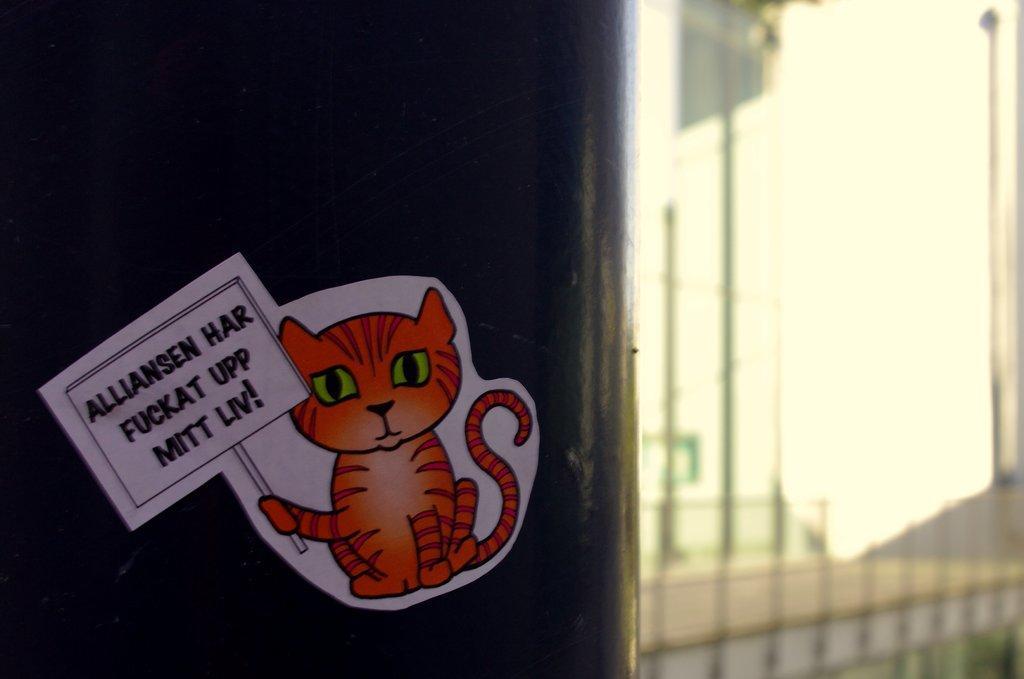Can you describe this image briefly? In this picture we can see the sticker of a cat holding a board. There are a few objects on the right side. We can see a blur view on the right side. 